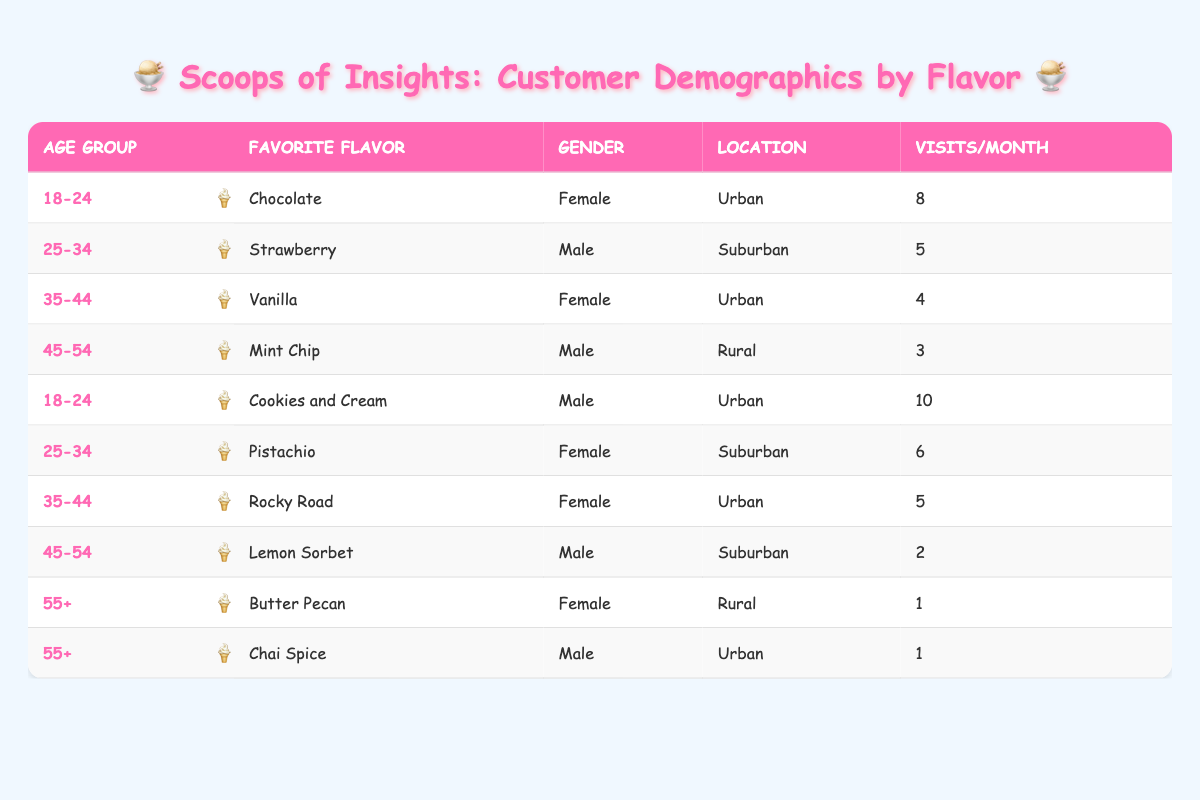What is the favorite ice cream flavor of the 18-24 age group? From the table, there are two entries for the age group 18-24: Chocolate and Cookies and Cream. Therefore, the favorite ice cream flavors in this age group are both Chocolate and Cookies and Cream.
Answer: Chocolate, Cookies and Cream How many times per month does a male in the 35-44 age group visit? The table shows one entry for the male in the 35-44 age group with a favorite flavor of Rocky Road, and he visits 5 times per month.
Answer: 5 True or False: The most frequent visitors belong to the 18-24 age group. Looking at the visits per month, the entries for the 18-24 age group are 8 and 10, which are the highest compared to other age groups, confirming that they are indeed the most frequent visitors.
Answer: True What is the total number of visits per month for the 55+ age group? There are two entries for the 55+ age group: Butter Pecan (1 visit) and Chai Spice (1 visit). Adding these gives a total of 1 + 1 = 2 visits per month for this age group.
Answer: 2 Which flavor is the least favorite among males? Examining the data, the least popular flavor in terms of visits is Lemon Sorbet for the 45-54 age group, where the male visits only 2 times per month.
Answer: Lemon Sorbet What is the difference in average visits per month between females and males in the 25-34 age group? The female for the 25-34 age group (Pistachio) visits 6 times per month, while the male (Strawberry) visits 5 times per month. The difference is 6 - 5 = 1.
Answer: 1 Do both urban and rural customers appear in every age group listed in the table? From the table, Not all age groups have representation from both urban and rural customers; specifically, the 45-54 age group has only rural entries and the 55+ age group has limited representation, so the statement is false.
Answer: False What is the most popular flavor among customers in suburban locations? The most popular flavor among suburban customers appears to be Strawberry (from the male in the 25-34 age group) with 5 visits, and Pistachio (from the female in the same age group) with 6 visits, giving Pistachio as the overall favorite.
Answer: Pistachio 